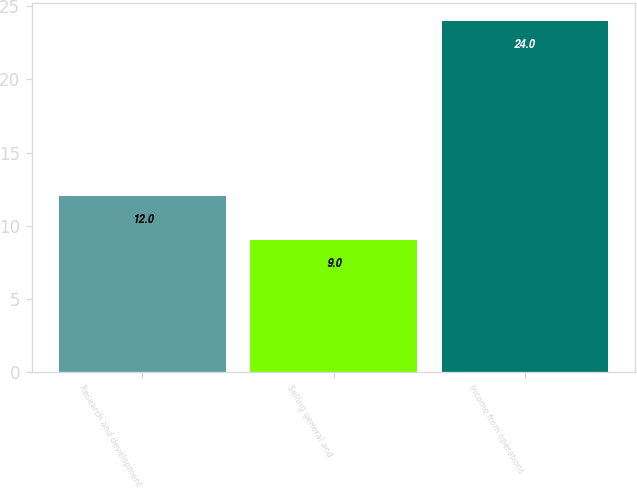<chart> <loc_0><loc_0><loc_500><loc_500><bar_chart><fcel>Research and development<fcel>Selling general and<fcel>Income from operations<nl><fcel>12<fcel>9<fcel>24<nl></chart> 